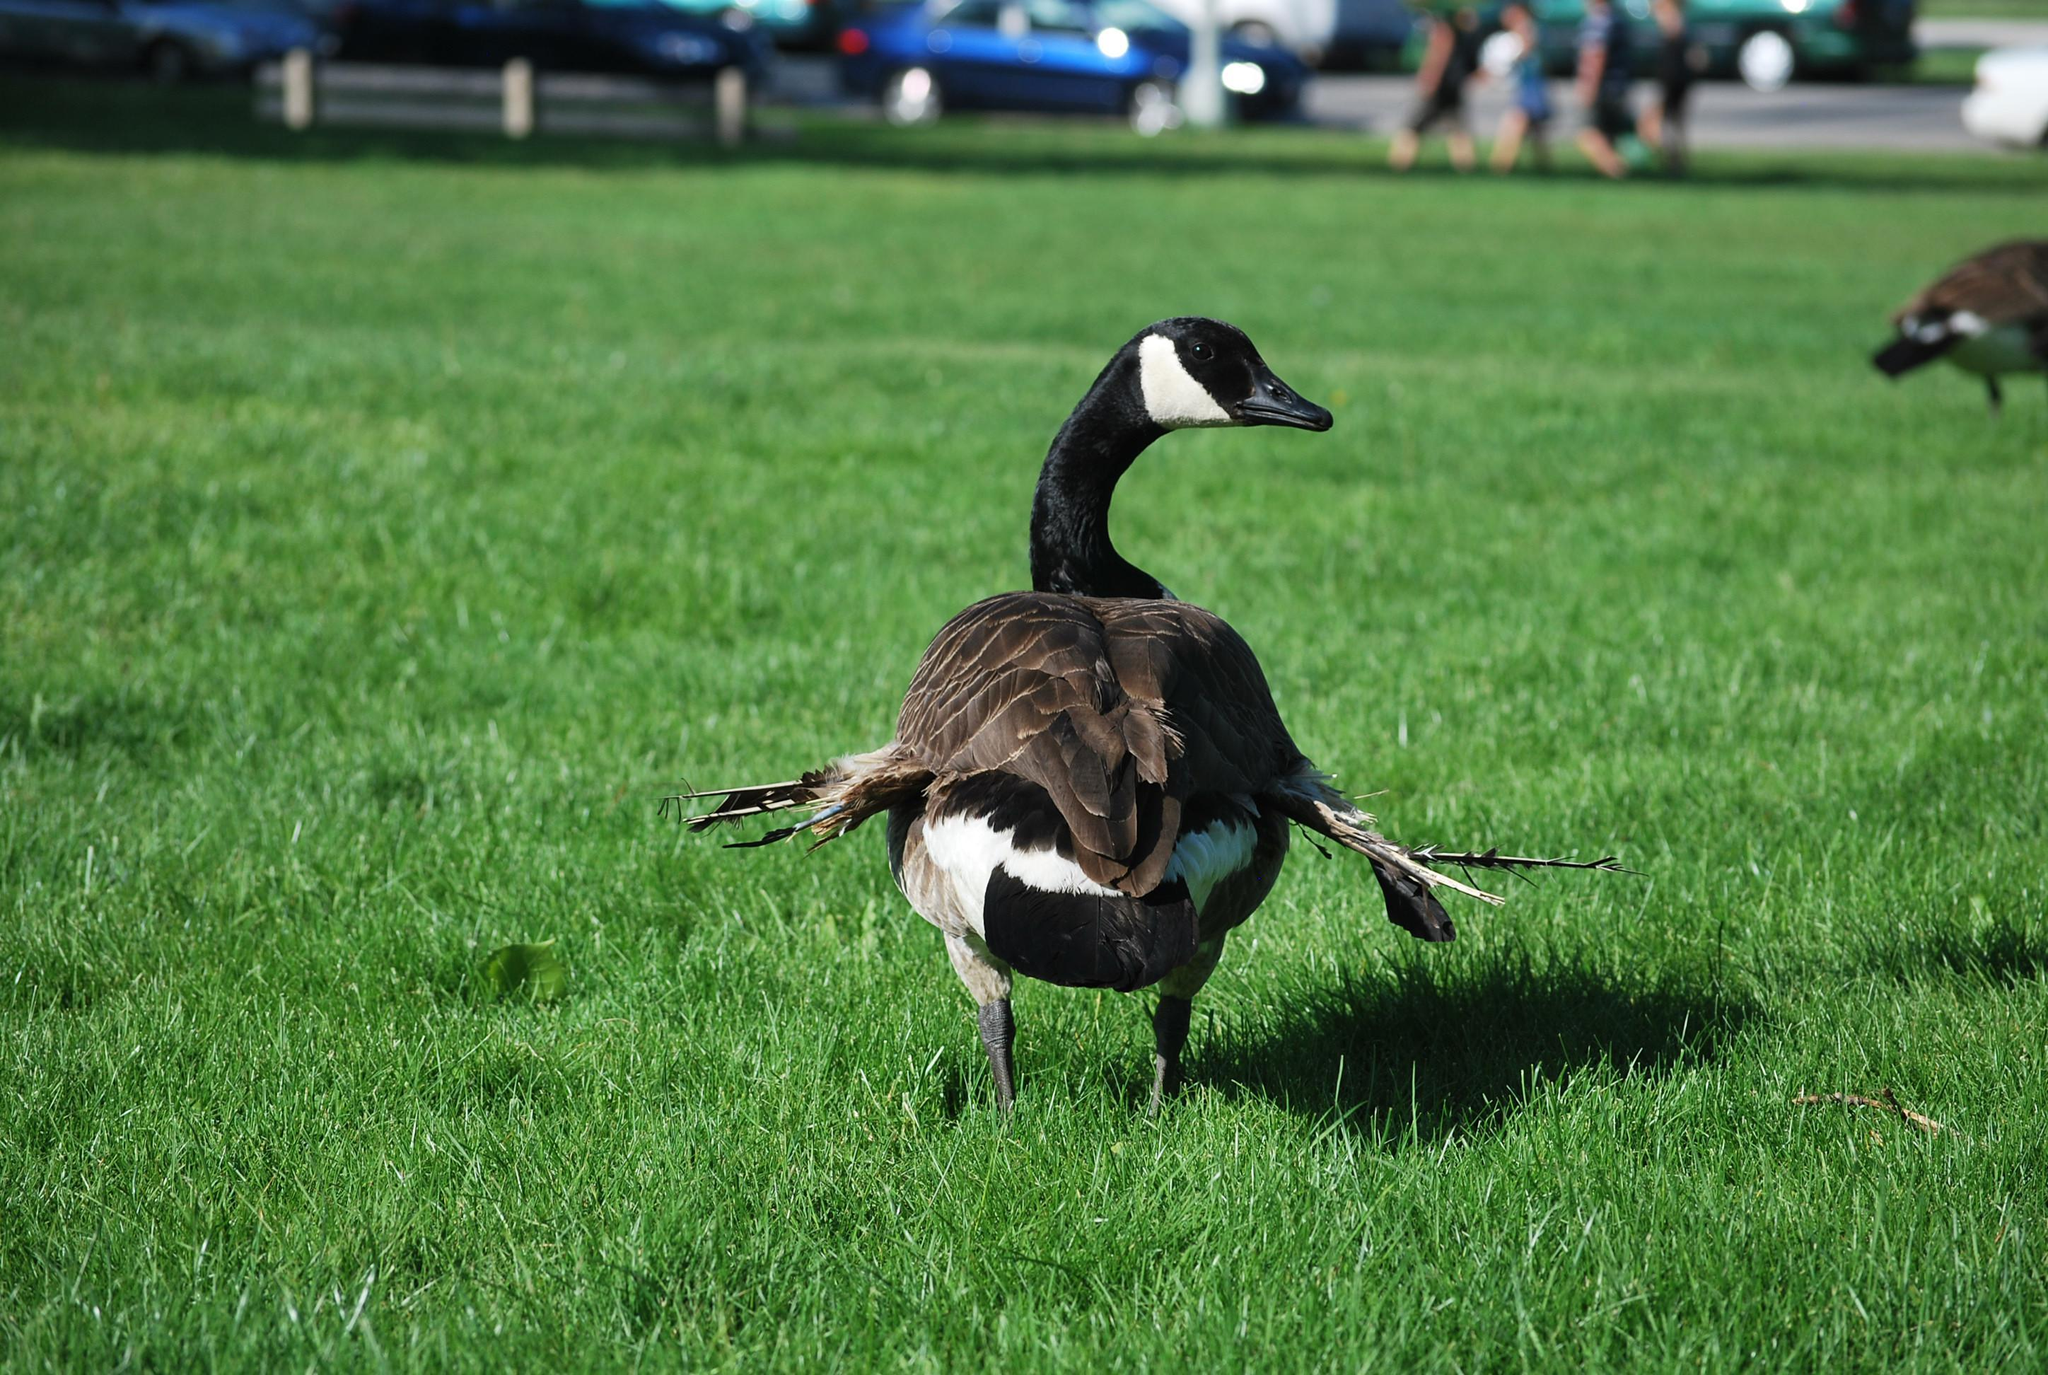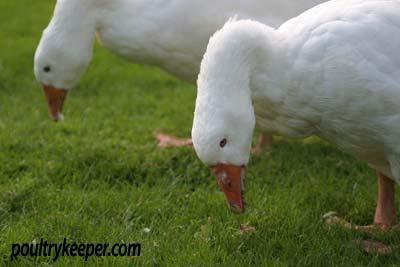The first image is the image on the left, the second image is the image on the right. For the images displayed, is the sentence "There is an image of a single goose that has its head bent to the ground." factually correct? Answer yes or no. No. The first image is the image on the left, the second image is the image on the right. Analyze the images presented: Is the assertion "There are no more than four birds." valid? Answer yes or no. Yes. 